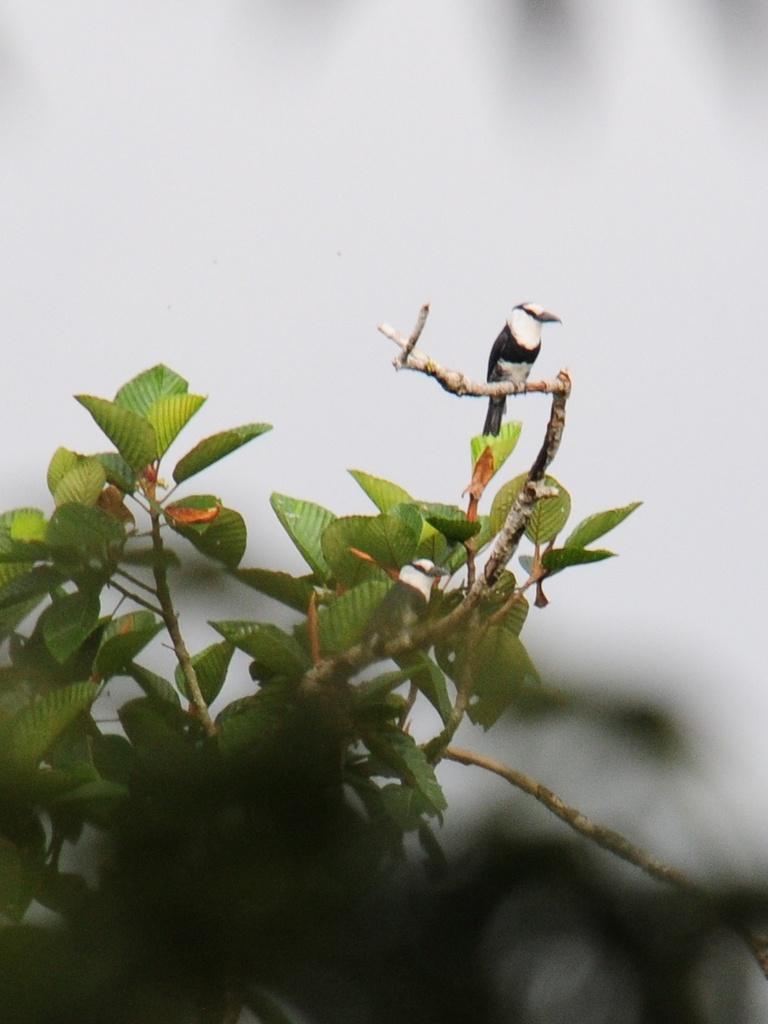Can you describe this image briefly? In the foreground of this picture we can see a bird standing on the stem of a plant. The background of the image is blurry. 